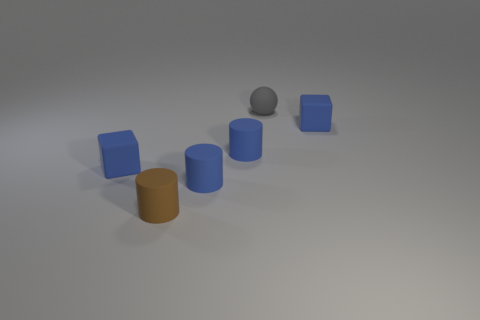What is the material of the tiny blue cube that is to the left of the brown rubber cylinder?
Ensure brevity in your answer.  Rubber. What number of small gray rubber things have the same shape as the tiny brown thing?
Offer a very short reply. 0. There is a brown object that is made of the same material as the gray ball; what is its shape?
Offer a terse response. Cylinder. The tiny gray thing that is right of the rubber cube on the left side of the matte block right of the ball is what shape?
Give a very brief answer. Sphere. Are there more blue objects than things?
Your answer should be very brief. No. Are there more rubber things behind the small brown cylinder than gray rubber things?
Make the answer very short. Yes. There is a small gray sphere on the right side of the tiny blue matte block that is in front of the object to the right of the tiny rubber ball; what is its material?
Keep it short and to the point. Rubber. What number of objects are blocks or small cubes that are on the right side of the gray rubber sphere?
Your response must be concise. 2. Is the number of small blue matte objects that are on the right side of the tiny brown thing greater than the number of blocks that are left of the gray rubber sphere?
Offer a very short reply. Yes. How many things are blue matte cylinders or gray matte things?
Ensure brevity in your answer.  3. 